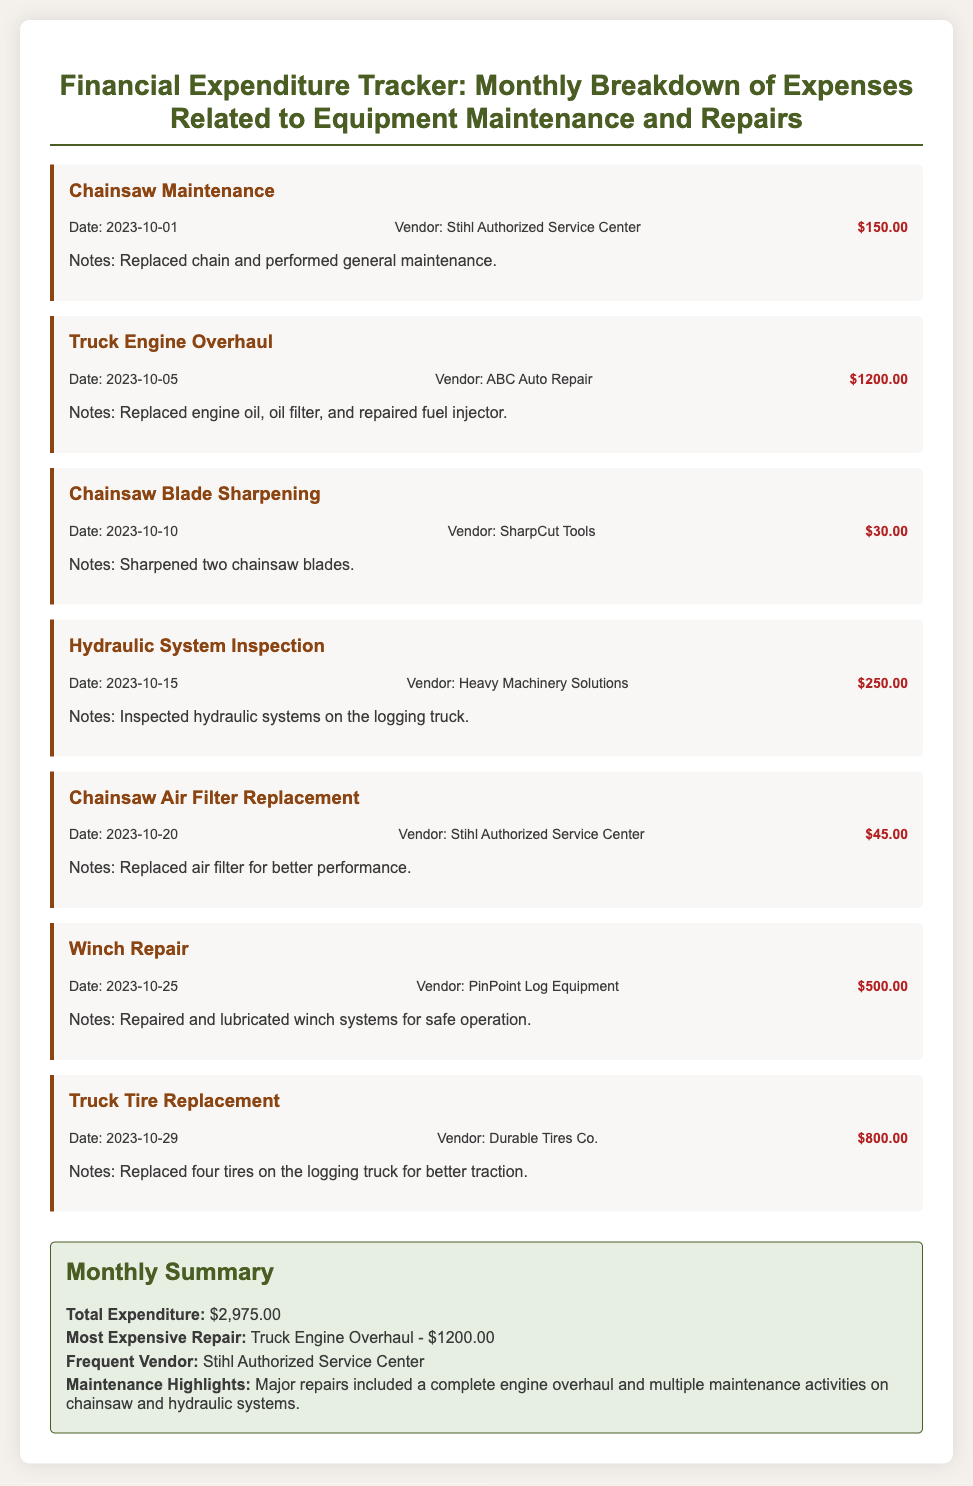What was the total expenditure for October? The total expenditure is listed in the monthly summary section as $2,975.00.
Answer: $2,975.00 What was the most expensive repair this month? The most expensive repair is specified in the summary as the Truck Engine Overhaul costing $1,200.00.
Answer: Truck Engine Overhaul - $1,200.00 Which vendor performed the chainsaw maintenance? The vendor that performed the chainsaw maintenance is mentioned in the log entry as Stihl Authorized Service Center.
Answer: Stihl Authorized Service Center How many tires were replaced on the logging truck? The log entry for the Truck Tire Replacement states that four tires were replaced.
Answer: Four What is the date of the Hydraulic System Inspection entry? The date for the Hydraulic System Inspection is provided in the log entry as 2023-10-15.
Answer: 2023-10-15 How many maintenance activities were logged for chainsaws? There are three entries logged for chainsaw maintenance and repairs: Chainsaw Maintenance, Chainsaw Blade Sharpening, and Chainsaw Air Filter Replacement.
Answer: Three Who is the frequent vendor mentioned in the summary? The summary section identifies the frequent vendor as Stihl Authorized Service Center.
Answer: Stihl Authorized Service Center What type of maintenance was performed on the winch? The log entry for the winch indicates it was repaired and lubricated for safe operation.
Answer: Repaired and lubricated What was done during the Truck Engine Overhaul? The log entry specifies that engine oil, oil filter, and fuel injector repairs were done during the overhaul.
Answer: Replaced engine oil, oil filter, and repaired fuel injector 